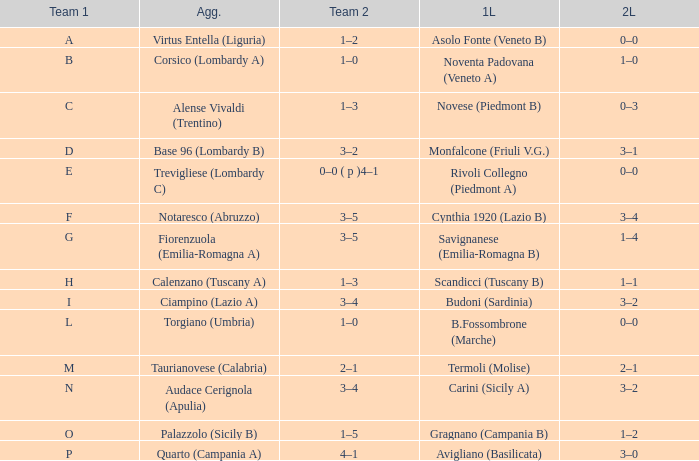What 1st leg has Alense Vivaldi (Trentino) as Agg.? Novese (Piedmont B). 